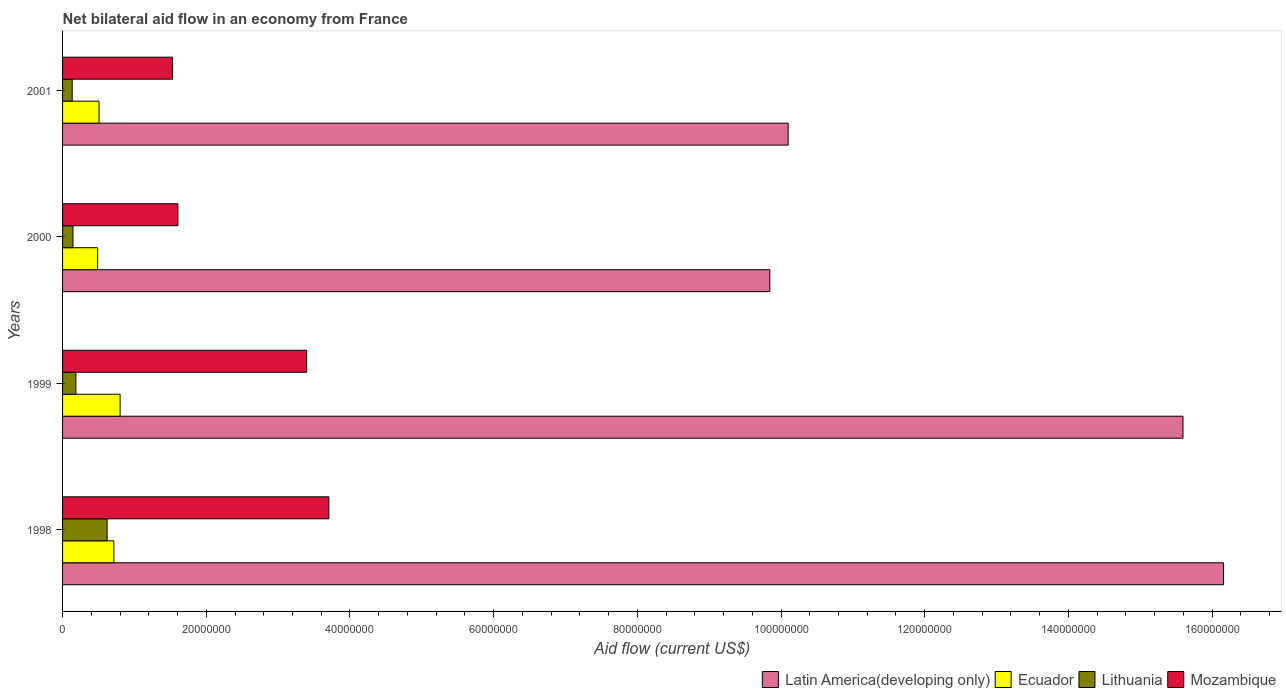How many different coloured bars are there?
Ensure brevity in your answer.  4. Are the number of bars per tick equal to the number of legend labels?
Provide a short and direct response. Yes. What is the label of the 4th group of bars from the top?
Make the answer very short. 1998. In how many cases, is the number of bars for a given year not equal to the number of legend labels?
Your answer should be very brief. 0. What is the net bilateral aid flow in Latin America(developing only) in 2001?
Provide a succinct answer. 1.01e+08. Across all years, what is the maximum net bilateral aid flow in Lithuania?
Keep it short and to the point. 6.20e+06. Across all years, what is the minimum net bilateral aid flow in Ecuador?
Keep it short and to the point. 4.88e+06. In which year was the net bilateral aid flow in Ecuador maximum?
Ensure brevity in your answer.  1999. In which year was the net bilateral aid flow in Latin America(developing only) minimum?
Ensure brevity in your answer.  2000. What is the total net bilateral aid flow in Lithuania in the graph?
Your answer should be compact. 1.08e+07. What is the difference between the net bilateral aid flow in Lithuania in 1998 and that in 2001?
Ensure brevity in your answer.  4.86e+06. What is the difference between the net bilateral aid flow in Latin America(developing only) in 2000 and the net bilateral aid flow in Lithuania in 1998?
Provide a short and direct response. 9.22e+07. What is the average net bilateral aid flow in Mozambique per year?
Ensure brevity in your answer.  2.56e+07. In the year 2001, what is the difference between the net bilateral aid flow in Mozambique and net bilateral aid flow in Ecuador?
Keep it short and to the point. 1.02e+07. What is the ratio of the net bilateral aid flow in Ecuador in 1999 to that in 2001?
Offer a very short reply. 1.58. Is the net bilateral aid flow in Lithuania in 1998 less than that in 1999?
Your answer should be very brief. No. Is the difference between the net bilateral aid flow in Mozambique in 1998 and 1999 greater than the difference between the net bilateral aid flow in Ecuador in 1998 and 1999?
Ensure brevity in your answer.  Yes. What is the difference between the highest and the second highest net bilateral aid flow in Mozambique?
Offer a terse response. 3.09e+06. What is the difference between the highest and the lowest net bilateral aid flow in Mozambique?
Provide a short and direct response. 2.18e+07. Is the sum of the net bilateral aid flow in Lithuania in 1998 and 1999 greater than the maximum net bilateral aid flow in Mozambique across all years?
Provide a succinct answer. No. Is it the case that in every year, the sum of the net bilateral aid flow in Lithuania and net bilateral aid flow in Latin America(developing only) is greater than the sum of net bilateral aid flow in Ecuador and net bilateral aid flow in Mozambique?
Provide a short and direct response. Yes. What does the 4th bar from the top in 1999 represents?
Keep it short and to the point. Latin America(developing only). What does the 2nd bar from the bottom in 2000 represents?
Provide a short and direct response. Ecuador. How many bars are there?
Offer a terse response. 16. What is the title of the graph?
Your answer should be compact. Net bilateral aid flow in an economy from France. What is the Aid flow (current US$) of Latin America(developing only) in 1998?
Offer a very short reply. 1.62e+08. What is the Aid flow (current US$) in Ecuador in 1998?
Make the answer very short. 7.14e+06. What is the Aid flow (current US$) of Lithuania in 1998?
Provide a succinct answer. 6.20e+06. What is the Aid flow (current US$) in Mozambique in 1998?
Give a very brief answer. 3.71e+07. What is the Aid flow (current US$) in Latin America(developing only) in 1999?
Offer a terse response. 1.56e+08. What is the Aid flow (current US$) of Ecuador in 1999?
Keep it short and to the point. 8.01e+06. What is the Aid flow (current US$) of Lithuania in 1999?
Provide a succinct answer. 1.85e+06. What is the Aid flow (current US$) of Mozambique in 1999?
Provide a succinct answer. 3.40e+07. What is the Aid flow (current US$) of Latin America(developing only) in 2000?
Your answer should be very brief. 9.84e+07. What is the Aid flow (current US$) in Ecuador in 2000?
Your answer should be compact. 4.88e+06. What is the Aid flow (current US$) in Lithuania in 2000?
Keep it short and to the point. 1.45e+06. What is the Aid flow (current US$) of Mozambique in 2000?
Your answer should be compact. 1.60e+07. What is the Aid flow (current US$) in Latin America(developing only) in 2001?
Your response must be concise. 1.01e+08. What is the Aid flow (current US$) of Ecuador in 2001?
Your answer should be compact. 5.08e+06. What is the Aid flow (current US$) of Lithuania in 2001?
Offer a very short reply. 1.34e+06. What is the Aid flow (current US$) of Mozambique in 2001?
Your answer should be very brief. 1.53e+07. Across all years, what is the maximum Aid flow (current US$) of Latin America(developing only)?
Offer a terse response. 1.62e+08. Across all years, what is the maximum Aid flow (current US$) of Ecuador?
Offer a very short reply. 8.01e+06. Across all years, what is the maximum Aid flow (current US$) of Lithuania?
Offer a terse response. 6.20e+06. Across all years, what is the maximum Aid flow (current US$) of Mozambique?
Ensure brevity in your answer.  3.71e+07. Across all years, what is the minimum Aid flow (current US$) in Latin America(developing only)?
Offer a very short reply. 9.84e+07. Across all years, what is the minimum Aid flow (current US$) in Ecuador?
Give a very brief answer. 4.88e+06. Across all years, what is the minimum Aid flow (current US$) in Lithuania?
Offer a terse response. 1.34e+06. Across all years, what is the minimum Aid flow (current US$) of Mozambique?
Offer a terse response. 1.53e+07. What is the total Aid flow (current US$) in Latin America(developing only) in the graph?
Make the answer very short. 5.17e+08. What is the total Aid flow (current US$) of Ecuador in the graph?
Give a very brief answer. 2.51e+07. What is the total Aid flow (current US$) of Lithuania in the graph?
Provide a short and direct response. 1.08e+07. What is the total Aid flow (current US$) of Mozambique in the graph?
Provide a short and direct response. 1.02e+08. What is the difference between the Aid flow (current US$) of Latin America(developing only) in 1998 and that in 1999?
Make the answer very short. 5.63e+06. What is the difference between the Aid flow (current US$) of Ecuador in 1998 and that in 1999?
Make the answer very short. -8.70e+05. What is the difference between the Aid flow (current US$) in Lithuania in 1998 and that in 1999?
Ensure brevity in your answer.  4.35e+06. What is the difference between the Aid flow (current US$) of Mozambique in 1998 and that in 1999?
Give a very brief answer. 3.09e+06. What is the difference between the Aid flow (current US$) of Latin America(developing only) in 1998 and that in 2000?
Your answer should be compact. 6.31e+07. What is the difference between the Aid flow (current US$) of Ecuador in 1998 and that in 2000?
Your answer should be very brief. 2.26e+06. What is the difference between the Aid flow (current US$) of Lithuania in 1998 and that in 2000?
Your answer should be compact. 4.75e+06. What is the difference between the Aid flow (current US$) in Mozambique in 1998 and that in 2000?
Your answer should be compact. 2.10e+07. What is the difference between the Aid flow (current US$) of Latin America(developing only) in 1998 and that in 2001?
Provide a succinct answer. 6.06e+07. What is the difference between the Aid flow (current US$) in Ecuador in 1998 and that in 2001?
Give a very brief answer. 2.06e+06. What is the difference between the Aid flow (current US$) of Lithuania in 1998 and that in 2001?
Provide a short and direct response. 4.86e+06. What is the difference between the Aid flow (current US$) in Mozambique in 1998 and that in 2001?
Provide a short and direct response. 2.18e+07. What is the difference between the Aid flow (current US$) of Latin America(developing only) in 1999 and that in 2000?
Give a very brief answer. 5.75e+07. What is the difference between the Aid flow (current US$) in Ecuador in 1999 and that in 2000?
Ensure brevity in your answer.  3.13e+06. What is the difference between the Aid flow (current US$) of Lithuania in 1999 and that in 2000?
Keep it short and to the point. 4.00e+05. What is the difference between the Aid flow (current US$) in Mozambique in 1999 and that in 2000?
Give a very brief answer. 1.79e+07. What is the difference between the Aid flow (current US$) in Latin America(developing only) in 1999 and that in 2001?
Keep it short and to the point. 5.50e+07. What is the difference between the Aid flow (current US$) of Ecuador in 1999 and that in 2001?
Keep it short and to the point. 2.93e+06. What is the difference between the Aid flow (current US$) of Lithuania in 1999 and that in 2001?
Make the answer very short. 5.10e+05. What is the difference between the Aid flow (current US$) of Mozambique in 1999 and that in 2001?
Offer a terse response. 1.87e+07. What is the difference between the Aid flow (current US$) of Latin America(developing only) in 2000 and that in 2001?
Your answer should be compact. -2.55e+06. What is the difference between the Aid flow (current US$) in Ecuador in 2000 and that in 2001?
Make the answer very short. -2.00e+05. What is the difference between the Aid flow (current US$) of Lithuania in 2000 and that in 2001?
Your answer should be very brief. 1.10e+05. What is the difference between the Aid flow (current US$) of Mozambique in 2000 and that in 2001?
Your response must be concise. 7.40e+05. What is the difference between the Aid flow (current US$) in Latin America(developing only) in 1998 and the Aid flow (current US$) in Ecuador in 1999?
Your answer should be compact. 1.54e+08. What is the difference between the Aid flow (current US$) of Latin America(developing only) in 1998 and the Aid flow (current US$) of Lithuania in 1999?
Ensure brevity in your answer.  1.60e+08. What is the difference between the Aid flow (current US$) in Latin America(developing only) in 1998 and the Aid flow (current US$) in Mozambique in 1999?
Your answer should be very brief. 1.28e+08. What is the difference between the Aid flow (current US$) of Ecuador in 1998 and the Aid flow (current US$) of Lithuania in 1999?
Make the answer very short. 5.29e+06. What is the difference between the Aid flow (current US$) in Ecuador in 1998 and the Aid flow (current US$) in Mozambique in 1999?
Your answer should be very brief. -2.68e+07. What is the difference between the Aid flow (current US$) in Lithuania in 1998 and the Aid flow (current US$) in Mozambique in 1999?
Keep it short and to the point. -2.78e+07. What is the difference between the Aid flow (current US$) of Latin America(developing only) in 1998 and the Aid flow (current US$) of Ecuador in 2000?
Your answer should be very brief. 1.57e+08. What is the difference between the Aid flow (current US$) in Latin America(developing only) in 1998 and the Aid flow (current US$) in Lithuania in 2000?
Your answer should be compact. 1.60e+08. What is the difference between the Aid flow (current US$) of Latin America(developing only) in 1998 and the Aid flow (current US$) of Mozambique in 2000?
Give a very brief answer. 1.46e+08. What is the difference between the Aid flow (current US$) of Ecuador in 1998 and the Aid flow (current US$) of Lithuania in 2000?
Ensure brevity in your answer.  5.69e+06. What is the difference between the Aid flow (current US$) in Ecuador in 1998 and the Aid flow (current US$) in Mozambique in 2000?
Your response must be concise. -8.91e+06. What is the difference between the Aid flow (current US$) in Lithuania in 1998 and the Aid flow (current US$) in Mozambique in 2000?
Offer a very short reply. -9.85e+06. What is the difference between the Aid flow (current US$) of Latin America(developing only) in 1998 and the Aid flow (current US$) of Ecuador in 2001?
Offer a very short reply. 1.56e+08. What is the difference between the Aid flow (current US$) of Latin America(developing only) in 1998 and the Aid flow (current US$) of Lithuania in 2001?
Offer a very short reply. 1.60e+08. What is the difference between the Aid flow (current US$) of Latin America(developing only) in 1998 and the Aid flow (current US$) of Mozambique in 2001?
Your response must be concise. 1.46e+08. What is the difference between the Aid flow (current US$) of Ecuador in 1998 and the Aid flow (current US$) of Lithuania in 2001?
Provide a short and direct response. 5.80e+06. What is the difference between the Aid flow (current US$) of Ecuador in 1998 and the Aid flow (current US$) of Mozambique in 2001?
Provide a short and direct response. -8.17e+06. What is the difference between the Aid flow (current US$) of Lithuania in 1998 and the Aid flow (current US$) of Mozambique in 2001?
Provide a short and direct response. -9.11e+06. What is the difference between the Aid flow (current US$) of Latin America(developing only) in 1999 and the Aid flow (current US$) of Ecuador in 2000?
Your answer should be very brief. 1.51e+08. What is the difference between the Aid flow (current US$) in Latin America(developing only) in 1999 and the Aid flow (current US$) in Lithuania in 2000?
Ensure brevity in your answer.  1.54e+08. What is the difference between the Aid flow (current US$) of Latin America(developing only) in 1999 and the Aid flow (current US$) of Mozambique in 2000?
Your answer should be compact. 1.40e+08. What is the difference between the Aid flow (current US$) of Ecuador in 1999 and the Aid flow (current US$) of Lithuania in 2000?
Offer a terse response. 6.56e+06. What is the difference between the Aid flow (current US$) in Ecuador in 1999 and the Aid flow (current US$) in Mozambique in 2000?
Ensure brevity in your answer.  -8.04e+06. What is the difference between the Aid flow (current US$) of Lithuania in 1999 and the Aid flow (current US$) of Mozambique in 2000?
Your response must be concise. -1.42e+07. What is the difference between the Aid flow (current US$) of Latin America(developing only) in 1999 and the Aid flow (current US$) of Ecuador in 2001?
Your response must be concise. 1.51e+08. What is the difference between the Aid flow (current US$) of Latin America(developing only) in 1999 and the Aid flow (current US$) of Lithuania in 2001?
Ensure brevity in your answer.  1.55e+08. What is the difference between the Aid flow (current US$) in Latin America(developing only) in 1999 and the Aid flow (current US$) in Mozambique in 2001?
Give a very brief answer. 1.41e+08. What is the difference between the Aid flow (current US$) in Ecuador in 1999 and the Aid flow (current US$) in Lithuania in 2001?
Offer a terse response. 6.67e+06. What is the difference between the Aid flow (current US$) in Ecuador in 1999 and the Aid flow (current US$) in Mozambique in 2001?
Offer a terse response. -7.30e+06. What is the difference between the Aid flow (current US$) of Lithuania in 1999 and the Aid flow (current US$) of Mozambique in 2001?
Provide a succinct answer. -1.35e+07. What is the difference between the Aid flow (current US$) in Latin America(developing only) in 2000 and the Aid flow (current US$) in Ecuador in 2001?
Provide a short and direct response. 9.34e+07. What is the difference between the Aid flow (current US$) in Latin America(developing only) in 2000 and the Aid flow (current US$) in Lithuania in 2001?
Make the answer very short. 9.71e+07. What is the difference between the Aid flow (current US$) of Latin America(developing only) in 2000 and the Aid flow (current US$) of Mozambique in 2001?
Keep it short and to the point. 8.31e+07. What is the difference between the Aid flow (current US$) in Ecuador in 2000 and the Aid flow (current US$) in Lithuania in 2001?
Offer a terse response. 3.54e+06. What is the difference between the Aid flow (current US$) of Ecuador in 2000 and the Aid flow (current US$) of Mozambique in 2001?
Ensure brevity in your answer.  -1.04e+07. What is the difference between the Aid flow (current US$) of Lithuania in 2000 and the Aid flow (current US$) of Mozambique in 2001?
Provide a short and direct response. -1.39e+07. What is the average Aid flow (current US$) in Latin America(developing only) per year?
Give a very brief answer. 1.29e+08. What is the average Aid flow (current US$) in Ecuador per year?
Your response must be concise. 6.28e+06. What is the average Aid flow (current US$) in Lithuania per year?
Keep it short and to the point. 2.71e+06. What is the average Aid flow (current US$) in Mozambique per year?
Offer a terse response. 2.56e+07. In the year 1998, what is the difference between the Aid flow (current US$) in Latin America(developing only) and Aid flow (current US$) in Ecuador?
Keep it short and to the point. 1.54e+08. In the year 1998, what is the difference between the Aid flow (current US$) in Latin America(developing only) and Aid flow (current US$) in Lithuania?
Ensure brevity in your answer.  1.55e+08. In the year 1998, what is the difference between the Aid flow (current US$) of Latin America(developing only) and Aid flow (current US$) of Mozambique?
Your answer should be compact. 1.25e+08. In the year 1998, what is the difference between the Aid flow (current US$) in Ecuador and Aid flow (current US$) in Lithuania?
Provide a short and direct response. 9.40e+05. In the year 1998, what is the difference between the Aid flow (current US$) in Ecuador and Aid flow (current US$) in Mozambique?
Offer a terse response. -2.99e+07. In the year 1998, what is the difference between the Aid flow (current US$) of Lithuania and Aid flow (current US$) of Mozambique?
Provide a short and direct response. -3.09e+07. In the year 1999, what is the difference between the Aid flow (current US$) of Latin America(developing only) and Aid flow (current US$) of Ecuador?
Your answer should be compact. 1.48e+08. In the year 1999, what is the difference between the Aid flow (current US$) in Latin America(developing only) and Aid flow (current US$) in Lithuania?
Give a very brief answer. 1.54e+08. In the year 1999, what is the difference between the Aid flow (current US$) in Latin America(developing only) and Aid flow (current US$) in Mozambique?
Keep it short and to the point. 1.22e+08. In the year 1999, what is the difference between the Aid flow (current US$) in Ecuador and Aid flow (current US$) in Lithuania?
Your response must be concise. 6.16e+06. In the year 1999, what is the difference between the Aid flow (current US$) in Ecuador and Aid flow (current US$) in Mozambique?
Your answer should be compact. -2.60e+07. In the year 1999, what is the difference between the Aid flow (current US$) of Lithuania and Aid flow (current US$) of Mozambique?
Offer a very short reply. -3.21e+07. In the year 2000, what is the difference between the Aid flow (current US$) in Latin America(developing only) and Aid flow (current US$) in Ecuador?
Provide a succinct answer. 9.36e+07. In the year 2000, what is the difference between the Aid flow (current US$) in Latin America(developing only) and Aid flow (current US$) in Lithuania?
Give a very brief answer. 9.70e+07. In the year 2000, what is the difference between the Aid flow (current US$) in Latin America(developing only) and Aid flow (current US$) in Mozambique?
Your answer should be compact. 8.24e+07. In the year 2000, what is the difference between the Aid flow (current US$) in Ecuador and Aid flow (current US$) in Lithuania?
Make the answer very short. 3.43e+06. In the year 2000, what is the difference between the Aid flow (current US$) in Ecuador and Aid flow (current US$) in Mozambique?
Provide a succinct answer. -1.12e+07. In the year 2000, what is the difference between the Aid flow (current US$) in Lithuania and Aid flow (current US$) in Mozambique?
Offer a very short reply. -1.46e+07. In the year 2001, what is the difference between the Aid flow (current US$) of Latin America(developing only) and Aid flow (current US$) of Ecuador?
Your response must be concise. 9.59e+07. In the year 2001, what is the difference between the Aid flow (current US$) of Latin America(developing only) and Aid flow (current US$) of Lithuania?
Your answer should be compact. 9.96e+07. In the year 2001, what is the difference between the Aid flow (current US$) of Latin America(developing only) and Aid flow (current US$) of Mozambique?
Your answer should be very brief. 8.57e+07. In the year 2001, what is the difference between the Aid flow (current US$) in Ecuador and Aid flow (current US$) in Lithuania?
Provide a succinct answer. 3.74e+06. In the year 2001, what is the difference between the Aid flow (current US$) of Ecuador and Aid flow (current US$) of Mozambique?
Keep it short and to the point. -1.02e+07. In the year 2001, what is the difference between the Aid flow (current US$) of Lithuania and Aid flow (current US$) of Mozambique?
Provide a succinct answer. -1.40e+07. What is the ratio of the Aid flow (current US$) in Latin America(developing only) in 1998 to that in 1999?
Ensure brevity in your answer.  1.04. What is the ratio of the Aid flow (current US$) of Ecuador in 1998 to that in 1999?
Your response must be concise. 0.89. What is the ratio of the Aid flow (current US$) in Lithuania in 1998 to that in 1999?
Offer a very short reply. 3.35. What is the ratio of the Aid flow (current US$) in Mozambique in 1998 to that in 1999?
Provide a succinct answer. 1.09. What is the ratio of the Aid flow (current US$) in Latin America(developing only) in 1998 to that in 2000?
Keep it short and to the point. 1.64. What is the ratio of the Aid flow (current US$) in Ecuador in 1998 to that in 2000?
Ensure brevity in your answer.  1.46. What is the ratio of the Aid flow (current US$) of Lithuania in 1998 to that in 2000?
Give a very brief answer. 4.28. What is the ratio of the Aid flow (current US$) in Mozambique in 1998 to that in 2000?
Provide a succinct answer. 2.31. What is the ratio of the Aid flow (current US$) in Latin America(developing only) in 1998 to that in 2001?
Give a very brief answer. 1.6. What is the ratio of the Aid flow (current US$) of Ecuador in 1998 to that in 2001?
Offer a terse response. 1.41. What is the ratio of the Aid flow (current US$) in Lithuania in 1998 to that in 2001?
Your answer should be very brief. 4.63. What is the ratio of the Aid flow (current US$) of Mozambique in 1998 to that in 2001?
Keep it short and to the point. 2.42. What is the ratio of the Aid flow (current US$) in Latin America(developing only) in 1999 to that in 2000?
Ensure brevity in your answer.  1.58. What is the ratio of the Aid flow (current US$) of Ecuador in 1999 to that in 2000?
Provide a short and direct response. 1.64. What is the ratio of the Aid flow (current US$) of Lithuania in 1999 to that in 2000?
Offer a very short reply. 1.28. What is the ratio of the Aid flow (current US$) in Mozambique in 1999 to that in 2000?
Your response must be concise. 2.12. What is the ratio of the Aid flow (current US$) of Latin America(developing only) in 1999 to that in 2001?
Your answer should be very brief. 1.54. What is the ratio of the Aid flow (current US$) in Ecuador in 1999 to that in 2001?
Provide a succinct answer. 1.58. What is the ratio of the Aid flow (current US$) of Lithuania in 1999 to that in 2001?
Offer a very short reply. 1.38. What is the ratio of the Aid flow (current US$) in Mozambique in 1999 to that in 2001?
Your answer should be compact. 2.22. What is the ratio of the Aid flow (current US$) of Latin America(developing only) in 2000 to that in 2001?
Give a very brief answer. 0.97. What is the ratio of the Aid flow (current US$) of Ecuador in 2000 to that in 2001?
Provide a short and direct response. 0.96. What is the ratio of the Aid flow (current US$) in Lithuania in 2000 to that in 2001?
Make the answer very short. 1.08. What is the ratio of the Aid flow (current US$) in Mozambique in 2000 to that in 2001?
Provide a succinct answer. 1.05. What is the difference between the highest and the second highest Aid flow (current US$) in Latin America(developing only)?
Your answer should be very brief. 5.63e+06. What is the difference between the highest and the second highest Aid flow (current US$) of Ecuador?
Keep it short and to the point. 8.70e+05. What is the difference between the highest and the second highest Aid flow (current US$) in Lithuania?
Provide a short and direct response. 4.35e+06. What is the difference between the highest and the second highest Aid flow (current US$) in Mozambique?
Ensure brevity in your answer.  3.09e+06. What is the difference between the highest and the lowest Aid flow (current US$) of Latin America(developing only)?
Your answer should be compact. 6.31e+07. What is the difference between the highest and the lowest Aid flow (current US$) in Ecuador?
Offer a very short reply. 3.13e+06. What is the difference between the highest and the lowest Aid flow (current US$) of Lithuania?
Your answer should be compact. 4.86e+06. What is the difference between the highest and the lowest Aid flow (current US$) of Mozambique?
Provide a succinct answer. 2.18e+07. 